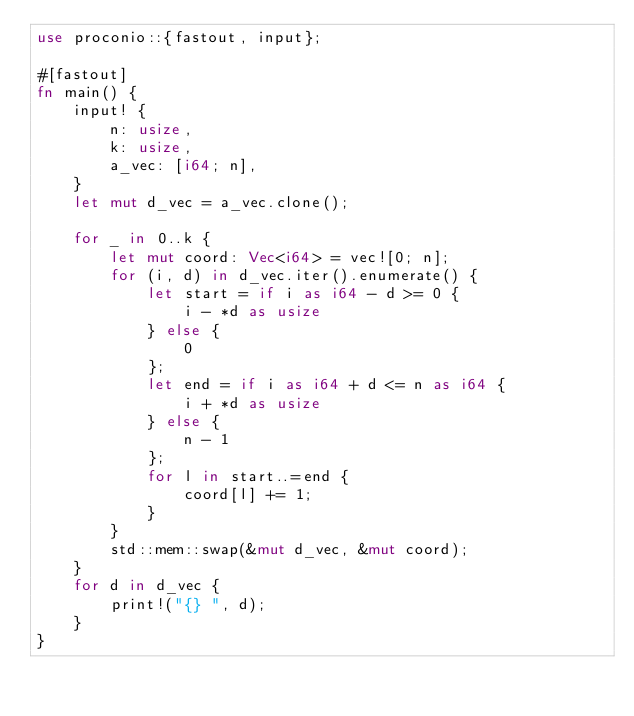<code> <loc_0><loc_0><loc_500><loc_500><_Rust_>use proconio::{fastout, input};

#[fastout]
fn main() {
    input! {
        n: usize,
        k: usize,
        a_vec: [i64; n],
    }
    let mut d_vec = a_vec.clone();

    for _ in 0..k {
        let mut coord: Vec<i64> = vec![0; n];
        for (i, d) in d_vec.iter().enumerate() {
            let start = if i as i64 - d >= 0 {
                i - *d as usize
            } else {
                0
            };
            let end = if i as i64 + d <= n as i64 {
                i + *d as usize
            } else {
                n - 1
            };
            for l in start..=end {
                coord[l] += 1;
            }
        }
        std::mem::swap(&mut d_vec, &mut coord);
    }
    for d in d_vec {
        print!("{} ", d);
    }
}
</code> 